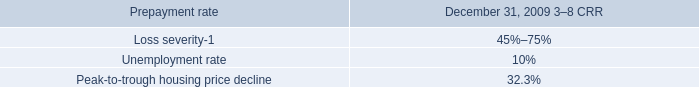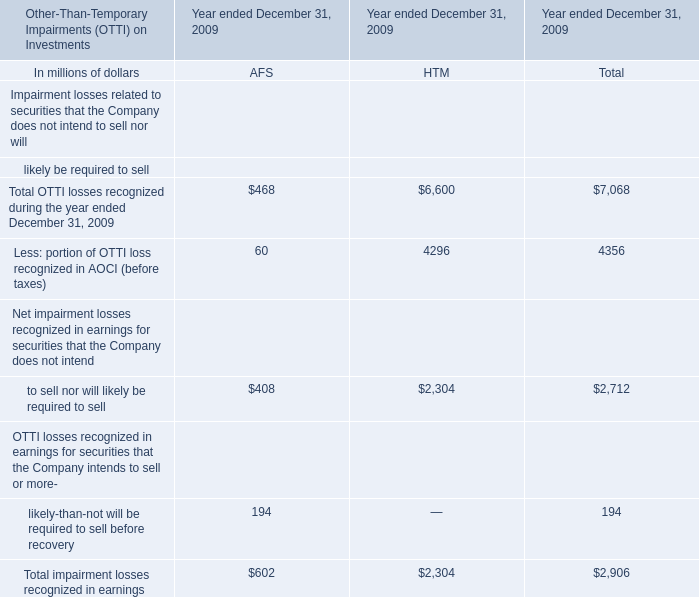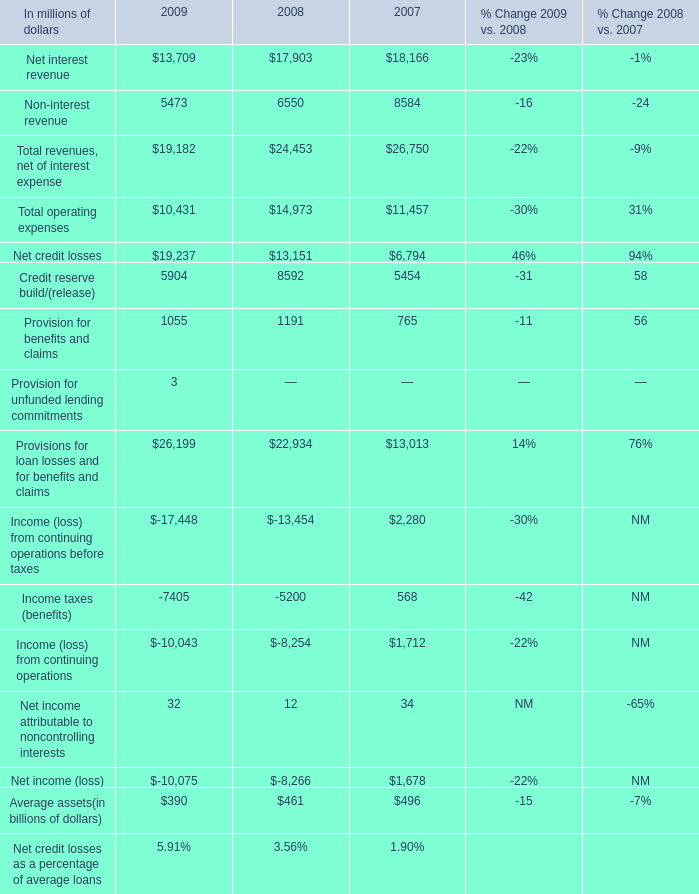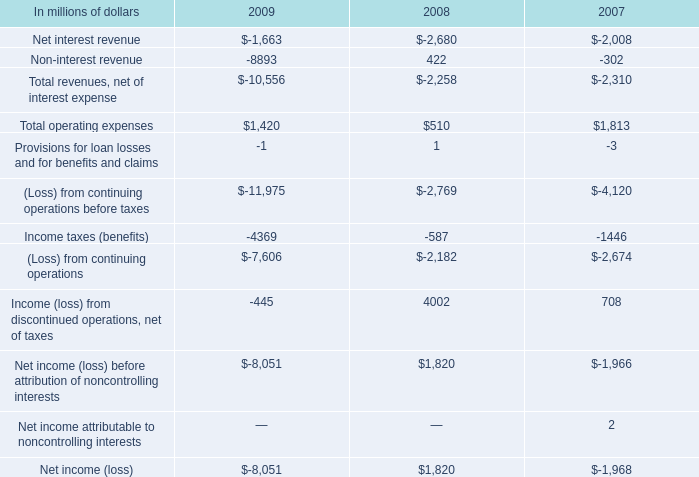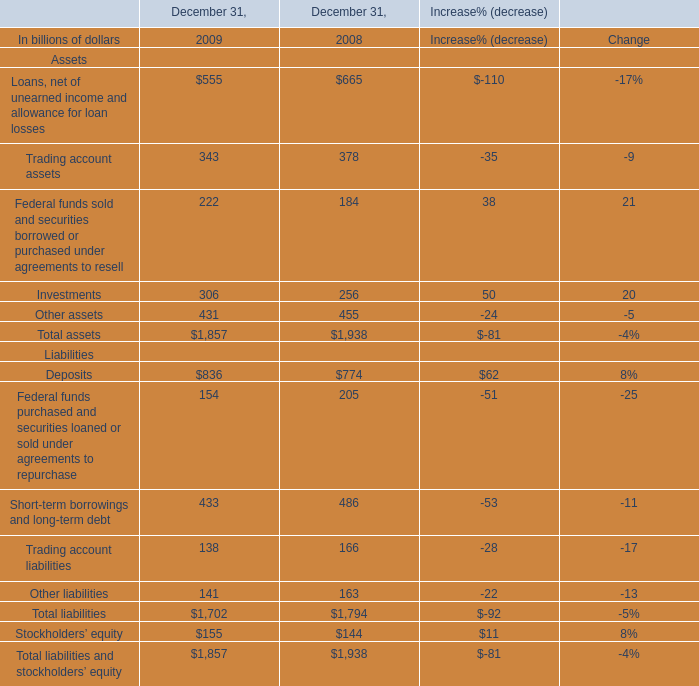what was the percentage change in total operating expenses between 2007 and 2008? 
Computations: ((510 - 1813) / 1813)
Answer: -0.7187. 